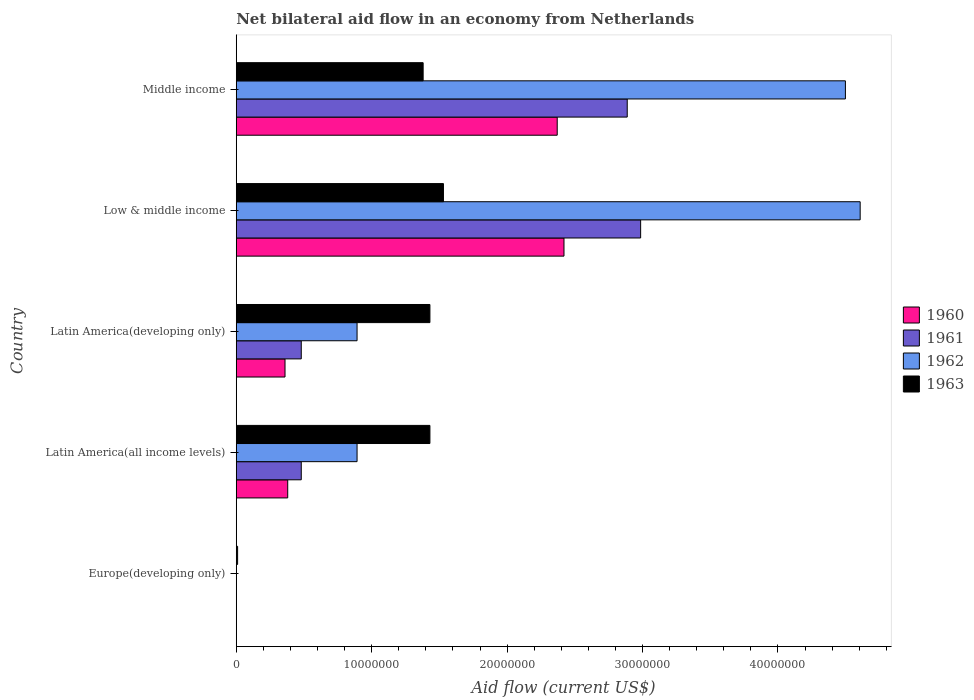How many different coloured bars are there?
Make the answer very short. 4. Are the number of bars on each tick of the Y-axis equal?
Make the answer very short. No. How many bars are there on the 5th tick from the bottom?
Your answer should be very brief. 4. What is the label of the 3rd group of bars from the top?
Keep it short and to the point. Latin America(developing only). In how many cases, is the number of bars for a given country not equal to the number of legend labels?
Keep it short and to the point. 1. What is the net bilateral aid flow in 1962 in Europe(developing only)?
Your answer should be very brief. 0. Across all countries, what is the maximum net bilateral aid flow in 1962?
Provide a short and direct response. 4.61e+07. Across all countries, what is the minimum net bilateral aid flow in 1963?
Your response must be concise. 1.00e+05. What is the total net bilateral aid flow in 1963 in the graph?
Make the answer very short. 5.78e+07. What is the difference between the net bilateral aid flow in 1963 in Europe(developing only) and that in Middle income?
Make the answer very short. -1.37e+07. What is the difference between the net bilateral aid flow in 1962 in Latin America(developing only) and the net bilateral aid flow in 1963 in Europe(developing only)?
Ensure brevity in your answer.  8.82e+06. What is the average net bilateral aid flow in 1960 per country?
Offer a terse response. 1.11e+07. What is the difference between the net bilateral aid flow in 1960 and net bilateral aid flow in 1962 in Middle income?
Make the answer very short. -2.13e+07. What is the ratio of the net bilateral aid flow in 1963 in Europe(developing only) to that in Latin America(all income levels)?
Your response must be concise. 0.01. Is the net bilateral aid flow in 1961 in Low & middle income less than that in Middle income?
Make the answer very short. No. What is the difference between the highest and the second highest net bilateral aid flow in 1961?
Your answer should be compact. 9.90e+05. What is the difference between the highest and the lowest net bilateral aid flow in 1962?
Your response must be concise. 4.61e+07. In how many countries, is the net bilateral aid flow in 1961 greater than the average net bilateral aid flow in 1961 taken over all countries?
Give a very brief answer. 2. Is it the case that in every country, the sum of the net bilateral aid flow in 1961 and net bilateral aid flow in 1963 is greater than the net bilateral aid flow in 1962?
Keep it short and to the point. No. How many countries are there in the graph?
Ensure brevity in your answer.  5. What is the difference between two consecutive major ticks on the X-axis?
Offer a very short reply. 1.00e+07. Are the values on the major ticks of X-axis written in scientific E-notation?
Provide a short and direct response. No. How many legend labels are there?
Provide a succinct answer. 4. How are the legend labels stacked?
Offer a terse response. Vertical. What is the title of the graph?
Give a very brief answer. Net bilateral aid flow in an economy from Netherlands. Does "1974" appear as one of the legend labels in the graph?
Provide a succinct answer. No. What is the label or title of the X-axis?
Offer a very short reply. Aid flow (current US$). What is the label or title of the Y-axis?
Keep it short and to the point. Country. What is the Aid flow (current US$) in 1960 in Europe(developing only)?
Ensure brevity in your answer.  0. What is the Aid flow (current US$) of 1962 in Europe(developing only)?
Your answer should be very brief. 0. What is the Aid flow (current US$) of 1960 in Latin America(all income levels)?
Give a very brief answer. 3.80e+06. What is the Aid flow (current US$) of 1961 in Latin America(all income levels)?
Make the answer very short. 4.80e+06. What is the Aid flow (current US$) of 1962 in Latin America(all income levels)?
Your response must be concise. 8.92e+06. What is the Aid flow (current US$) in 1963 in Latin America(all income levels)?
Offer a very short reply. 1.43e+07. What is the Aid flow (current US$) of 1960 in Latin America(developing only)?
Offer a terse response. 3.60e+06. What is the Aid flow (current US$) of 1961 in Latin America(developing only)?
Keep it short and to the point. 4.80e+06. What is the Aid flow (current US$) of 1962 in Latin America(developing only)?
Provide a short and direct response. 8.92e+06. What is the Aid flow (current US$) of 1963 in Latin America(developing only)?
Give a very brief answer. 1.43e+07. What is the Aid flow (current US$) in 1960 in Low & middle income?
Offer a terse response. 2.42e+07. What is the Aid flow (current US$) of 1961 in Low & middle income?
Your answer should be very brief. 2.99e+07. What is the Aid flow (current US$) in 1962 in Low & middle income?
Your response must be concise. 4.61e+07. What is the Aid flow (current US$) in 1963 in Low & middle income?
Offer a terse response. 1.53e+07. What is the Aid flow (current US$) of 1960 in Middle income?
Provide a succinct answer. 2.37e+07. What is the Aid flow (current US$) of 1961 in Middle income?
Keep it short and to the point. 2.89e+07. What is the Aid flow (current US$) of 1962 in Middle income?
Ensure brevity in your answer.  4.50e+07. What is the Aid flow (current US$) in 1963 in Middle income?
Your answer should be very brief. 1.38e+07. Across all countries, what is the maximum Aid flow (current US$) of 1960?
Keep it short and to the point. 2.42e+07. Across all countries, what is the maximum Aid flow (current US$) of 1961?
Your answer should be very brief. 2.99e+07. Across all countries, what is the maximum Aid flow (current US$) of 1962?
Provide a succinct answer. 4.61e+07. Across all countries, what is the maximum Aid flow (current US$) of 1963?
Offer a terse response. 1.53e+07. Across all countries, what is the minimum Aid flow (current US$) in 1960?
Ensure brevity in your answer.  0. Across all countries, what is the minimum Aid flow (current US$) in 1961?
Your response must be concise. 0. Across all countries, what is the minimum Aid flow (current US$) in 1963?
Provide a succinct answer. 1.00e+05. What is the total Aid flow (current US$) in 1960 in the graph?
Your answer should be very brief. 5.53e+07. What is the total Aid flow (current US$) of 1961 in the graph?
Offer a terse response. 6.83e+07. What is the total Aid flow (current US$) in 1962 in the graph?
Your answer should be very brief. 1.09e+08. What is the total Aid flow (current US$) of 1963 in the graph?
Provide a succinct answer. 5.78e+07. What is the difference between the Aid flow (current US$) in 1963 in Europe(developing only) and that in Latin America(all income levels)?
Your answer should be compact. -1.42e+07. What is the difference between the Aid flow (current US$) of 1963 in Europe(developing only) and that in Latin America(developing only)?
Ensure brevity in your answer.  -1.42e+07. What is the difference between the Aid flow (current US$) of 1963 in Europe(developing only) and that in Low & middle income?
Your answer should be very brief. -1.52e+07. What is the difference between the Aid flow (current US$) of 1963 in Europe(developing only) and that in Middle income?
Make the answer very short. -1.37e+07. What is the difference between the Aid flow (current US$) of 1960 in Latin America(all income levels) and that in Latin America(developing only)?
Provide a succinct answer. 2.00e+05. What is the difference between the Aid flow (current US$) in 1960 in Latin America(all income levels) and that in Low & middle income?
Give a very brief answer. -2.04e+07. What is the difference between the Aid flow (current US$) of 1961 in Latin America(all income levels) and that in Low & middle income?
Provide a short and direct response. -2.51e+07. What is the difference between the Aid flow (current US$) in 1962 in Latin America(all income levels) and that in Low & middle income?
Offer a terse response. -3.72e+07. What is the difference between the Aid flow (current US$) in 1963 in Latin America(all income levels) and that in Low & middle income?
Give a very brief answer. -1.00e+06. What is the difference between the Aid flow (current US$) of 1960 in Latin America(all income levels) and that in Middle income?
Make the answer very short. -1.99e+07. What is the difference between the Aid flow (current US$) of 1961 in Latin America(all income levels) and that in Middle income?
Provide a short and direct response. -2.41e+07. What is the difference between the Aid flow (current US$) in 1962 in Latin America(all income levels) and that in Middle income?
Make the answer very short. -3.61e+07. What is the difference between the Aid flow (current US$) in 1960 in Latin America(developing only) and that in Low & middle income?
Make the answer very short. -2.06e+07. What is the difference between the Aid flow (current US$) in 1961 in Latin America(developing only) and that in Low & middle income?
Provide a succinct answer. -2.51e+07. What is the difference between the Aid flow (current US$) of 1962 in Latin America(developing only) and that in Low & middle income?
Ensure brevity in your answer.  -3.72e+07. What is the difference between the Aid flow (current US$) of 1960 in Latin America(developing only) and that in Middle income?
Make the answer very short. -2.01e+07. What is the difference between the Aid flow (current US$) of 1961 in Latin America(developing only) and that in Middle income?
Offer a very short reply. -2.41e+07. What is the difference between the Aid flow (current US$) of 1962 in Latin America(developing only) and that in Middle income?
Your response must be concise. -3.61e+07. What is the difference between the Aid flow (current US$) in 1961 in Low & middle income and that in Middle income?
Your answer should be compact. 9.90e+05. What is the difference between the Aid flow (current US$) of 1962 in Low & middle income and that in Middle income?
Give a very brief answer. 1.09e+06. What is the difference between the Aid flow (current US$) in 1963 in Low & middle income and that in Middle income?
Offer a terse response. 1.50e+06. What is the difference between the Aid flow (current US$) of 1960 in Latin America(all income levels) and the Aid flow (current US$) of 1962 in Latin America(developing only)?
Provide a succinct answer. -5.12e+06. What is the difference between the Aid flow (current US$) in 1960 in Latin America(all income levels) and the Aid flow (current US$) in 1963 in Latin America(developing only)?
Your response must be concise. -1.05e+07. What is the difference between the Aid flow (current US$) in 1961 in Latin America(all income levels) and the Aid flow (current US$) in 1962 in Latin America(developing only)?
Your answer should be compact. -4.12e+06. What is the difference between the Aid flow (current US$) in 1961 in Latin America(all income levels) and the Aid flow (current US$) in 1963 in Latin America(developing only)?
Your answer should be compact. -9.50e+06. What is the difference between the Aid flow (current US$) in 1962 in Latin America(all income levels) and the Aid flow (current US$) in 1963 in Latin America(developing only)?
Keep it short and to the point. -5.38e+06. What is the difference between the Aid flow (current US$) in 1960 in Latin America(all income levels) and the Aid flow (current US$) in 1961 in Low & middle income?
Your response must be concise. -2.61e+07. What is the difference between the Aid flow (current US$) of 1960 in Latin America(all income levels) and the Aid flow (current US$) of 1962 in Low & middle income?
Offer a very short reply. -4.23e+07. What is the difference between the Aid flow (current US$) in 1960 in Latin America(all income levels) and the Aid flow (current US$) in 1963 in Low & middle income?
Provide a short and direct response. -1.15e+07. What is the difference between the Aid flow (current US$) in 1961 in Latin America(all income levels) and the Aid flow (current US$) in 1962 in Low & middle income?
Your answer should be compact. -4.13e+07. What is the difference between the Aid flow (current US$) of 1961 in Latin America(all income levels) and the Aid flow (current US$) of 1963 in Low & middle income?
Your response must be concise. -1.05e+07. What is the difference between the Aid flow (current US$) of 1962 in Latin America(all income levels) and the Aid flow (current US$) of 1963 in Low & middle income?
Provide a succinct answer. -6.38e+06. What is the difference between the Aid flow (current US$) in 1960 in Latin America(all income levels) and the Aid flow (current US$) in 1961 in Middle income?
Provide a succinct answer. -2.51e+07. What is the difference between the Aid flow (current US$) in 1960 in Latin America(all income levels) and the Aid flow (current US$) in 1962 in Middle income?
Your answer should be compact. -4.12e+07. What is the difference between the Aid flow (current US$) of 1960 in Latin America(all income levels) and the Aid flow (current US$) of 1963 in Middle income?
Ensure brevity in your answer.  -1.00e+07. What is the difference between the Aid flow (current US$) in 1961 in Latin America(all income levels) and the Aid flow (current US$) in 1962 in Middle income?
Your response must be concise. -4.02e+07. What is the difference between the Aid flow (current US$) in 1961 in Latin America(all income levels) and the Aid flow (current US$) in 1963 in Middle income?
Give a very brief answer. -9.00e+06. What is the difference between the Aid flow (current US$) in 1962 in Latin America(all income levels) and the Aid flow (current US$) in 1963 in Middle income?
Provide a succinct answer. -4.88e+06. What is the difference between the Aid flow (current US$) of 1960 in Latin America(developing only) and the Aid flow (current US$) of 1961 in Low & middle income?
Provide a succinct answer. -2.63e+07. What is the difference between the Aid flow (current US$) of 1960 in Latin America(developing only) and the Aid flow (current US$) of 1962 in Low & middle income?
Keep it short and to the point. -4.25e+07. What is the difference between the Aid flow (current US$) of 1960 in Latin America(developing only) and the Aid flow (current US$) of 1963 in Low & middle income?
Offer a very short reply. -1.17e+07. What is the difference between the Aid flow (current US$) of 1961 in Latin America(developing only) and the Aid flow (current US$) of 1962 in Low & middle income?
Keep it short and to the point. -4.13e+07. What is the difference between the Aid flow (current US$) of 1961 in Latin America(developing only) and the Aid flow (current US$) of 1963 in Low & middle income?
Your answer should be very brief. -1.05e+07. What is the difference between the Aid flow (current US$) of 1962 in Latin America(developing only) and the Aid flow (current US$) of 1963 in Low & middle income?
Offer a terse response. -6.38e+06. What is the difference between the Aid flow (current US$) in 1960 in Latin America(developing only) and the Aid flow (current US$) in 1961 in Middle income?
Your response must be concise. -2.53e+07. What is the difference between the Aid flow (current US$) of 1960 in Latin America(developing only) and the Aid flow (current US$) of 1962 in Middle income?
Offer a very short reply. -4.14e+07. What is the difference between the Aid flow (current US$) of 1960 in Latin America(developing only) and the Aid flow (current US$) of 1963 in Middle income?
Provide a short and direct response. -1.02e+07. What is the difference between the Aid flow (current US$) in 1961 in Latin America(developing only) and the Aid flow (current US$) in 1962 in Middle income?
Offer a terse response. -4.02e+07. What is the difference between the Aid flow (current US$) in 1961 in Latin America(developing only) and the Aid flow (current US$) in 1963 in Middle income?
Your response must be concise. -9.00e+06. What is the difference between the Aid flow (current US$) in 1962 in Latin America(developing only) and the Aid flow (current US$) in 1963 in Middle income?
Give a very brief answer. -4.88e+06. What is the difference between the Aid flow (current US$) in 1960 in Low & middle income and the Aid flow (current US$) in 1961 in Middle income?
Make the answer very short. -4.67e+06. What is the difference between the Aid flow (current US$) in 1960 in Low & middle income and the Aid flow (current US$) in 1962 in Middle income?
Offer a terse response. -2.08e+07. What is the difference between the Aid flow (current US$) of 1960 in Low & middle income and the Aid flow (current US$) of 1963 in Middle income?
Your response must be concise. 1.04e+07. What is the difference between the Aid flow (current US$) of 1961 in Low & middle income and the Aid flow (current US$) of 1962 in Middle income?
Keep it short and to the point. -1.51e+07. What is the difference between the Aid flow (current US$) in 1961 in Low & middle income and the Aid flow (current US$) in 1963 in Middle income?
Your answer should be very brief. 1.61e+07. What is the difference between the Aid flow (current US$) of 1962 in Low & middle income and the Aid flow (current US$) of 1963 in Middle income?
Offer a very short reply. 3.23e+07. What is the average Aid flow (current US$) of 1960 per country?
Your response must be concise. 1.11e+07. What is the average Aid flow (current US$) of 1961 per country?
Your answer should be compact. 1.37e+07. What is the average Aid flow (current US$) in 1962 per country?
Keep it short and to the point. 2.18e+07. What is the average Aid flow (current US$) of 1963 per country?
Make the answer very short. 1.16e+07. What is the difference between the Aid flow (current US$) of 1960 and Aid flow (current US$) of 1962 in Latin America(all income levels)?
Ensure brevity in your answer.  -5.12e+06. What is the difference between the Aid flow (current US$) of 1960 and Aid flow (current US$) of 1963 in Latin America(all income levels)?
Offer a very short reply. -1.05e+07. What is the difference between the Aid flow (current US$) in 1961 and Aid flow (current US$) in 1962 in Latin America(all income levels)?
Keep it short and to the point. -4.12e+06. What is the difference between the Aid flow (current US$) in 1961 and Aid flow (current US$) in 1963 in Latin America(all income levels)?
Offer a terse response. -9.50e+06. What is the difference between the Aid flow (current US$) in 1962 and Aid flow (current US$) in 1963 in Latin America(all income levels)?
Ensure brevity in your answer.  -5.38e+06. What is the difference between the Aid flow (current US$) of 1960 and Aid flow (current US$) of 1961 in Latin America(developing only)?
Offer a very short reply. -1.20e+06. What is the difference between the Aid flow (current US$) of 1960 and Aid flow (current US$) of 1962 in Latin America(developing only)?
Keep it short and to the point. -5.32e+06. What is the difference between the Aid flow (current US$) in 1960 and Aid flow (current US$) in 1963 in Latin America(developing only)?
Keep it short and to the point. -1.07e+07. What is the difference between the Aid flow (current US$) of 1961 and Aid flow (current US$) of 1962 in Latin America(developing only)?
Offer a terse response. -4.12e+06. What is the difference between the Aid flow (current US$) in 1961 and Aid flow (current US$) in 1963 in Latin America(developing only)?
Offer a very short reply. -9.50e+06. What is the difference between the Aid flow (current US$) in 1962 and Aid flow (current US$) in 1963 in Latin America(developing only)?
Your response must be concise. -5.38e+06. What is the difference between the Aid flow (current US$) of 1960 and Aid flow (current US$) of 1961 in Low & middle income?
Keep it short and to the point. -5.66e+06. What is the difference between the Aid flow (current US$) of 1960 and Aid flow (current US$) of 1962 in Low & middle income?
Keep it short and to the point. -2.19e+07. What is the difference between the Aid flow (current US$) of 1960 and Aid flow (current US$) of 1963 in Low & middle income?
Offer a terse response. 8.90e+06. What is the difference between the Aid flow (current US$) of 1961 and Aid flow (current US$) of 1962 in Low & middle income?
Your answer should be compact. -1.62e+07. What is the difference between the Aid flow (current US$) of 1961 and Aid flow (current US$) of 1963 in Low & middle income?
Your response must be concise. 1.46e+07. What is the difference between the Aid flow (current US$) in 1962 and Aid flow (current US$) in 1963 in Low & middle income?
Keep it short and to the point. 3.08e+07. What is the difference between the Aid flow (current US$) of 1960 and Aid flow (current US$) of 1961 in Middle income?
Ensure brevity in your answer.  -5.17e+06. What is the difference between the Aid flow (current US$) in 1960 and Aid flow (current US$) in 1962 in Middle income?
Offer a very short reply. -2.13e+07. What is the difference between the Aid flow (current US$) in 1960 and Aid flow (current US$) in 1963 in Middle income?
Your response must be concise. 9.90e+06. What is the difference between the Aid flow (current US$) in 1961 and Aid flow (current US$) in 1962 in Middle income?
Provide a short and direct response. -1.61e+07. What is the difference between the Aid flow (current US$) of 1961 and Aid flow (current US$) of 1963 in Middle income?
Ensure brevity in your answer.  1.51e+07. What is the difference between the Aid flow (current US$) in 1962 and Aid flow (current US$) in 1963 in Middle income?
Your answer should be compact. 3.12e+07. What is the ratio of the Aid flow (current US$) of 1963 in Europe(developing only) to that in Latin America(all income levels)?
Your response must be concise. 0.01. What is the ratio of the Aid flow (current US$) in 1963 in Europe(developing only) to that in Latin America(developing only)?
Your answer should be compact. 0.01. What is the ratio of the Aid flow (current US$) of 1963 in Europe(developing only) to that in Low & middle income?
Provide a succinct answer. 0.01. What is the ratio of the Aid flow (current US$) of 1963 in Europe(developing only) to that in Middle income?
Provide a succinct answer. 0.01. What is the ratio of the Aid flow (current US$) of 1960 in Latin America(all income levels) to that in Latin America(developing only)?
Offer a terse response. 1.06. What is the ratio of the Aid flow (current US$) of 1961 in Latin America(all income levels) to that in Latin America(developing only)?
Your answer should be compact. 1. What is the ratio of the Aid flow (current US$) in 1960 in Latin America(all income levels) to that in Low & middle income?
Ensure brevity in your answer.  0.16. What is the ratio of the Aid flow (current US$) in 1961 in Latin America(all income levels) to that in Low & middle income?
Keep it short and to the point. 0.16. What is the ratio of the Aid flow (current US$) in 1962 in Latin America(all income levels) to that in Low & middle income?
Offer a very short reply. 0.19. What is the ratio of the Aid flow (current US$) in 1963 in Latin America(all income levels) to that in Low & middle income?
Your answer should be very brief. 0.93. What is the ratio of the Aid flow (current US$) in 1960 in Latin America(all income levels) to that in Middle income?
Provide a short and direct response. 0.16. What is the ratio of the Aid flow (current US$) in 1961 in Latin America(all income levels) to that in Middle income?
Offer a very short reply. 0.17. What is the ratio of the Aid flow (current US$) in 1962 in Latin America(all income levels) to that in Middle income?
Ensure brevity in your answer.  0.2. What is the ratio of the Aid flow (current US$) of 1963 in Latin America(all income levels) to that in Middle income?
Your response must be concise. 1.04. What is the ratio of the Aid flow (current US$) of 1960 in Latin America(developing only) to that in Low & middle income?
Keep it short and to the point. 0.15. What is the ratio of the Aid flow (current US$) in 1961 in Latin America(developing only) to that in Low & middle income?
Make the answer very short. 0.16. What is the ratio of the Aid flow (current US$) of 1962 in Latin America(developing only) to that in Low & middle income?
Ensure brevity in your answer.  0.19. What is the ratio of the Aid flow (current US$) in 1963 in Latin America(developing only) to that in Low & middle income?
Give a very brief answer. 0.93. What is the ratio of the Aid flow (current US$) in 1960 in Latin America(developing only) to that in Middle income?
Make the answer very short. 0.15. What is the ratio of the Aid flow (current US$) of 1961 in Latin America(developing only) to that in Middle income?
Keep it short and to the point. 0.17. What is the ratio of the Aid flow (current US$) in 1962 in Latin America(developing only) to that in Middle income?
Ensure brevity in your answer.  0.2. What is the ratio of the Aid flow (current US$) in 1963 in Latin America(developing only) to that in Middle income?
Offer a very short reply. 1.04. What is the ratio of the Aid flow (current US$) in 1960 in Low & middle income to that in Middle income?
Offer a very short reply. 1.02. What is the ratio of the Aid flow (current US$) in 1961 in Low & middle income to that in Middle income?
Offer a terse response. 1.03. What is the ratio of the Aid flow (current US$) in 1962 in Low & middle income to that in Middle income?
Provide a succinct answer. 1.02. What is the ratio of the Aid flow (current US$) in 1963 in Low & middle income to that in Middle income?
Your response must be concise. 1.11. What is the difference between the highest and the second highest Aid flow (current US$) in 1960?
Keep it short and to the point. 5.00e+05. What is the difference between the highest and the second highest Aid flow (current US$) of 1961?
Make the answer very short. 9.90e+05. What is the difference between the highest and the second highest Aid flow (current US$) in 1962?
Your answer should be compact. 1.09e+06. What is the difference between the highest and the lowest Aid flow (current US$) of 1960?
Provide a succinct answer. 2.42e+07. What is the difference between the highest and the lowest Aid flow (current US$) in 1961?
Give a very brief answer. 2.99e+07. What is the difference between the highest and the lowest Aid flow (current US$) of 1962?
Make the answer very short. 4.61e+07. What is the difference between the highest and the lowest Aid flow (current US$) in 1963?
Your response must be concise. 1.52e+07. 